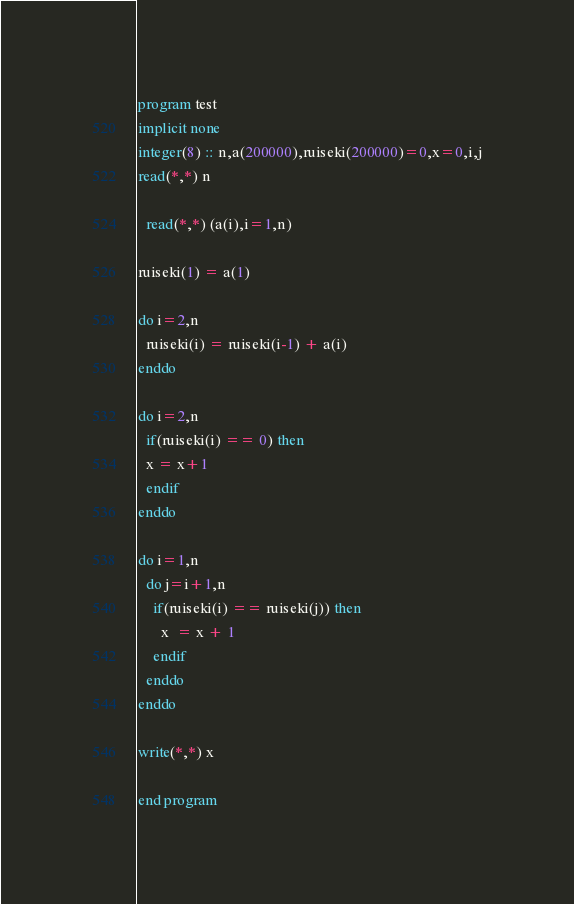<code> <loc_0><loc_0><loc_500><loc_500><_FORTRAN_>program test
implicit none
integer(8) :: n,a(200000),ruiseki(200000)=0,x=0,i,j
read(*,*) n

  read(*,*) (a(i),i=1,n)

ruiseki(1) = a(1)
 
do i=2,n
  ruiseki(i) = ruiseki(i-1) + a(i)
enddo

do i=2,n
  if(ruiseki(i) == 0) then
  x = x+1
  endif
enddo

do i=1,n
  do j=i+1,n
    if(ruiseki(i) == ruiseki(j)) then
      x  = x + 1
    endif
  enddo
enddo

write(*,*) x

end program</code> 